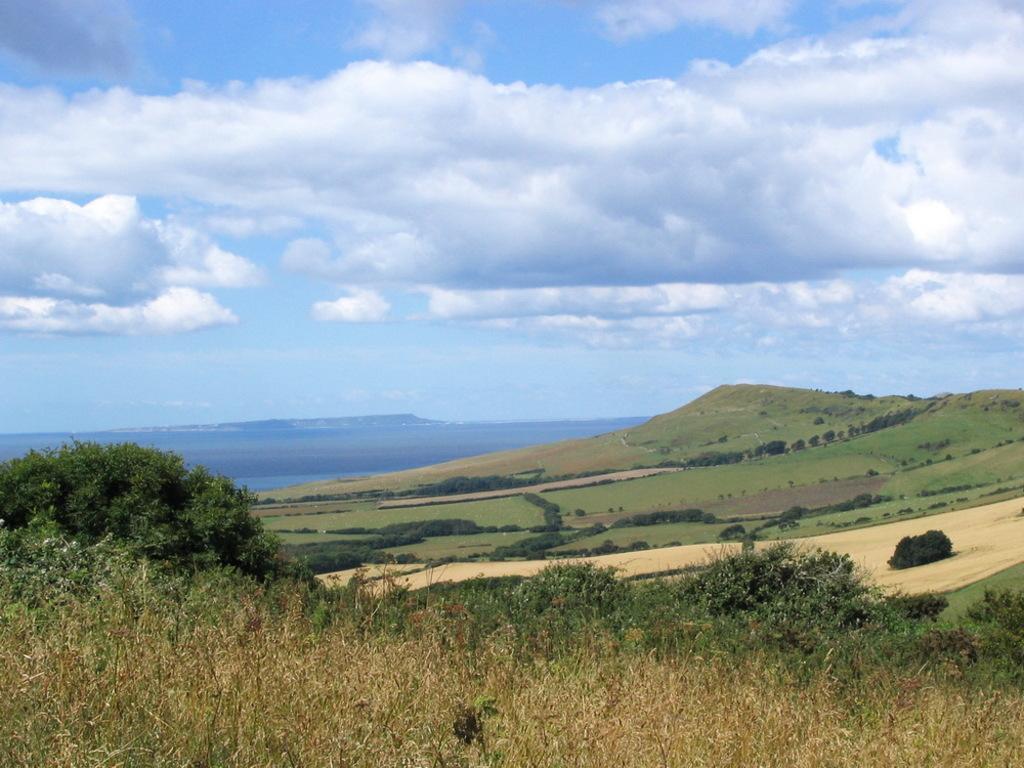Can you describe this image briefly? In this image, we can see some plants and trees. There is a hill on the right side of the image. There are clouds in the sky. 